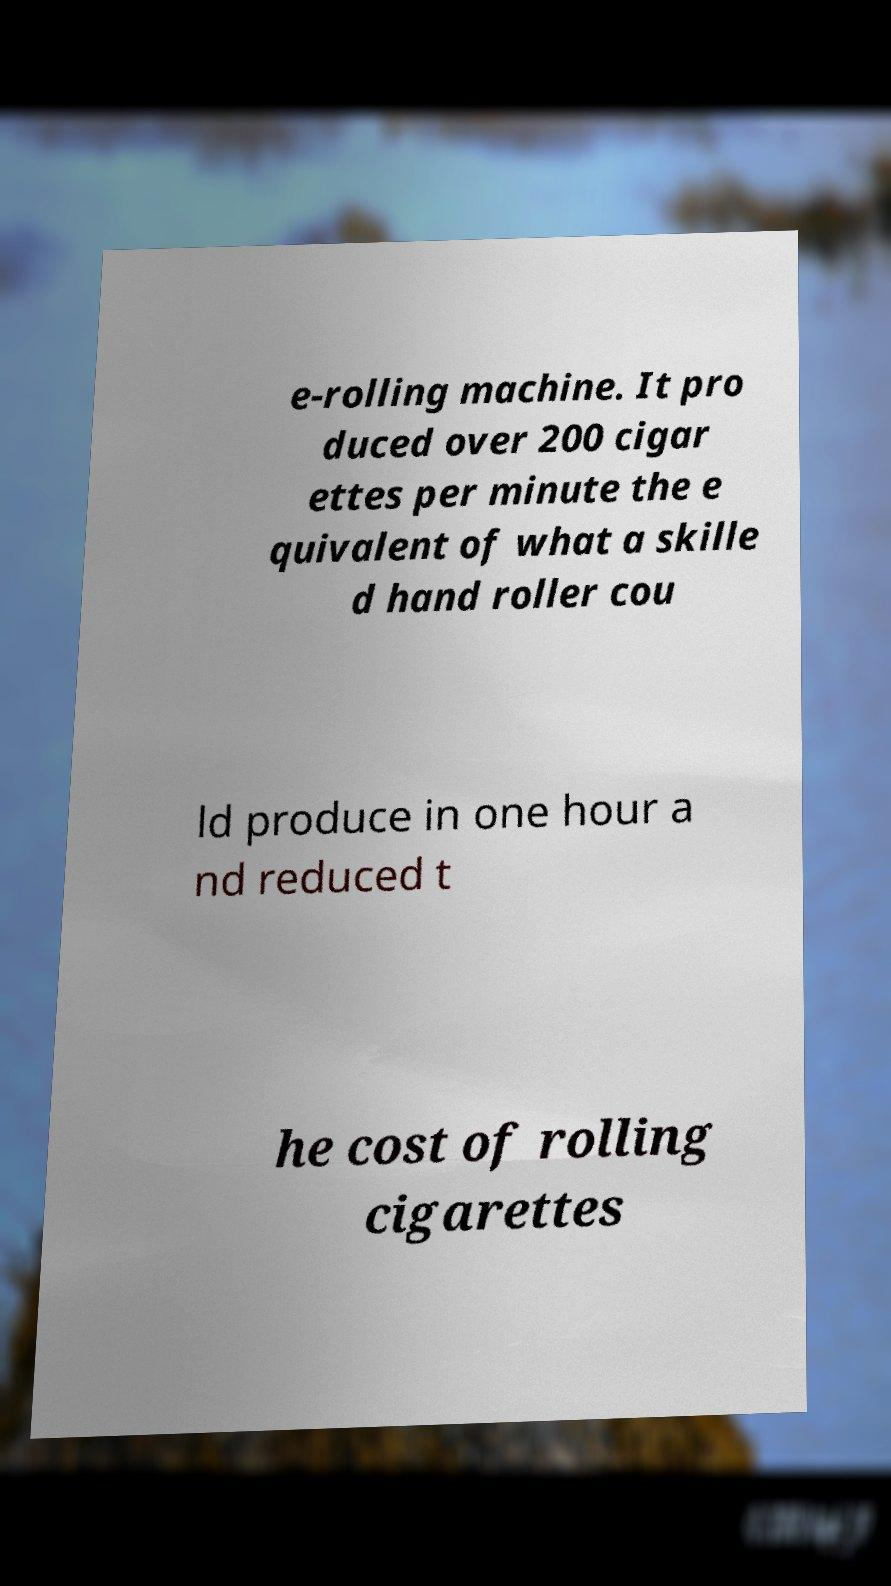I need the written content from this picture converted into text. Can you do that? e-rolling machine. It pro duced over 200 cigar ettes per minute the e quivalent of what a skille d hand roller cou ld produce in one hour a nd reduced t he cost of rolling cigarettes 